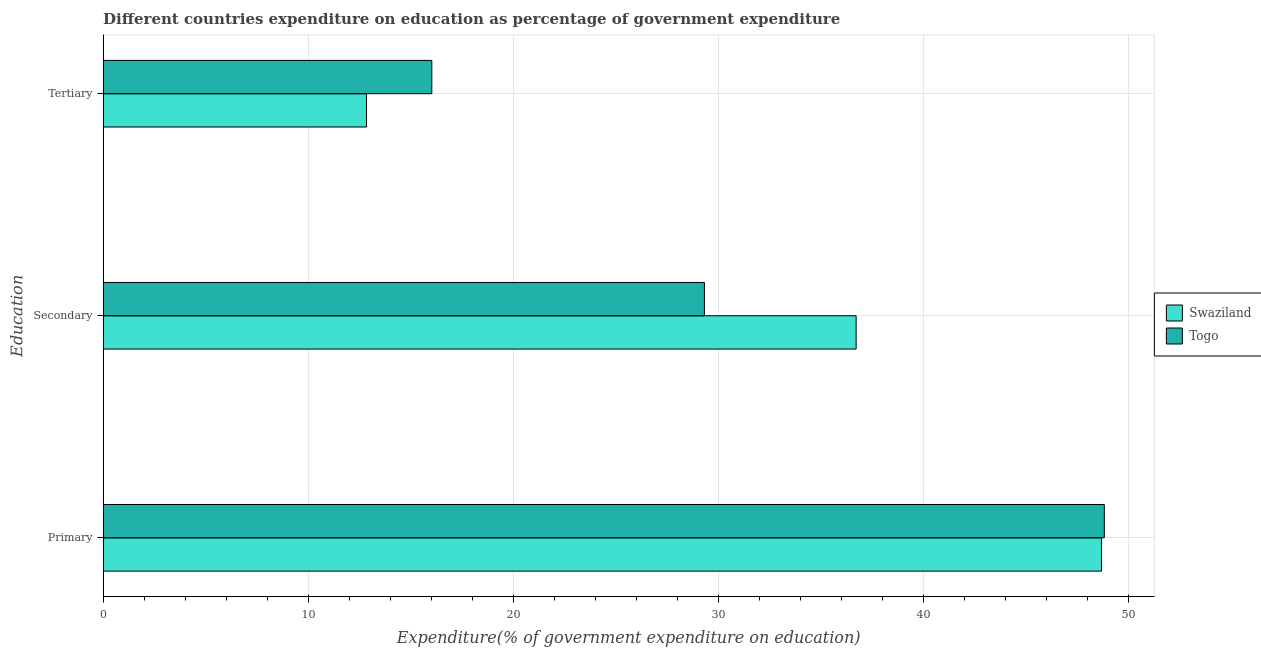Are the number of bars per tick equal to the number of legend labels?
Provide a short and direct response. Yes. How many bars are there on the 2nd tick from the top?
Keep it short and to the point. 2. What is the label of the 2nd group of bars from the top?
Your answer should be compact. Secondary. What is the expenditure on primary education in Swaziland?
Your answer should be very brief. 48.67. Across all countries, what is the maximum expenditure on secondary education?
Your answer should be very brief. 36.71. Across all countries, what is the minimum expenditure on tertiary education?
Give a very brief answer. 12.84. In which country was the expenditure on secondary education maximum?
Provide a short and direct response. Swaziland. In which country was the expenditure on tertiary education minimum?
Your answer should be very brief. Swaziland. What is the total expenditure on tertiary education in the graph?
Your answer should be very brief. 28.86. What is the difference between the expenditure on primary education in Togo and that in Swaziland?
Offer a very short reply. 0.14. What is the difference between the expenditure on secondary education in Swaziland and the expenditure on primary education in Togo?
Keep it short and to the point. -12.1. What is the average expenditure on tertiary education per country?
Make the answer very short. 14.43. What is the difference between the expenditure on tertiary education and expenditure on secondary education in Togo?
Provide a succinct answer. -13.29. In how many countries, is the expenditure on secondary education greater than 24 %?
Keep it short and to the point. 2. What is the ratio of the expenditure on primary education in Swaziland to that in Togo?
Ensure brevity in your answer.  1. Is the expenditure on primary education in Swaziland less than that in Togo?
Offer a very short reply. Yes. Is the difference between the expenditure on secondary education in Swaziland and Togo greater than the difference between the expenditure on tertiary education in Swaziland and Togo?
Offer a very short reply. Yes. What is the difference between the highest and the second highest expenditure on secondary education?
Offer a very short reply. 7.4. What is the difference between the highest and the lowest expenditure on tertiary education?
Offer a terse response. 3.18. Is the sum of the expenditure on tertiary education in Swaziland and Togo greater than the maximum expenditure on secondary education across all countries?
Ensure brevity in your answer.  No. What does the 1st bar from the top in Secondary represents?
Your response must be concise. Togo. What does the 2nd bar from the bottom in Primary represents?
Your response must be concise. Togo. Does the graph contain grids?
Provide a short and direct response. Yes. How many legend labels are there?
Keep it short and to the point. 2. How are the legend labels stacked?
Your answer should be compact. Vertical. What is the title of the graph?
Your answer should be compact. Different countries expenditure on education as percentage of government expenditure. Does "Pakistan" appear as one of the legend labels in the graph?
Provide a short and direct response. No. What is the label or title of the X-axis?
Ensure brevity in your answer.  Expenditure(% of government expenditure on education). What is the label or title of the Y-axis?
Ensure brevity in your answer.  Education. What is the Expenditure(% of government expenditure on education) in Swaziland in Primary?
Provide a succinct answer. 48.67. What is the Expenditure(% of government expenditure on education) in Togo in Primary?
Provide a succinct answer. 48.8. What is the Expenditure(% of government expenditure on education) in Swaziland in Secondary?
Provide a succinct answer. 36.71. What is the Expenditure(% of government expenditure on education) in Togo in Secondary?
Keep it short and to the point. 29.31. What is the Expenditure(% of government expenditure on education) of Swaziland in Tertiary?
Provide a succinct answer. 12.84. What is the Expenditure(% of government expenditure on education) of Togo in Tertiary?
Provide a short and direct response. 16.02. Across all Education, what is the maximum Expenditure(% of government expenditure on education) of Swaziland?
Ensure brevity in your answer.  48.67. Across all Education, what is the maximum Expenditure(% of government expenditure on education) of Togo?
Your response must be concise. 48.8. Across all Education, what is the minimum Expenditure(% of government expenditure on education) in Swaziland?
Offer a very short reply. 12.84. Across all Education, what is the minimum Expenditure(% of government expenditure on education) in Togo?
Make the answer very short. 16.02. What is the total Expenditure(% of government expenditure on education) of Swaziland in the graph?
Keep it short and to the point. 98.21. What is the total Expenditure(% of government expenditure on education) of Togo in the graph?
Keep it short and to the point. 94.14. What is the difference between the Expenditure(% of government expenditure on education) in Swaziland in Primary and that in Secondary?
Your response must be concise. 11.96. What is the difference between the Expenditure(% of government expenditure on education) of Togo in Primary and that in Secondary?
Give a very brief answer. 19.49. What is the difference between the Expenditure(% of government expenditure on education) of Swaziland in Primary and that in Tertiary?
Make the answer very short. 35.83. What is the difference between the Expenditure(% of government expenditure on education) in Togo in Primary and that in Tertiary?
Your answer should be very brief. 32.78. What is the difference between the Expenditure(% of government expenditure on education) in Swaziland in Secondary and that in Tertiary?
Make the answer very short. 23.87. What is the difference between the Expenditure(% of government expenditure on education) of Togo in Secondary and that in Tertiary?
Provide a succinct answer. 13.29. What is the difference between the Expenditure(% of government expenditure on education) of Swaziland in Primary and the Expenditure(% of government expenditure on education) of Togo in Secondary?
Offer a terse response. 19.36. What is the difference between the Expenditure(% of government expenditure on education) of Swaziland in Primary and the Expenditure(% of government expenditure on education) of Togo in Tertiary?
Offer a terse response. 32.65. What is the difference between the Expenditure(% of government expenditure on education) in Swaziland in Secondary and the Expenditure(% of government expenditure on education) in Togo in Tertiary?
Keep it short and to the point. 20.68. What is the average Expenditure(% of government expenditure on education) in Swaziland per Education?
Provide a short and direct response. 32.74. What is the average Expenditure(% of government expenditure on education) of Togo per Education?
Offer a very short reply. 31.38. What is the difference between the Expenditure(% of government expenditure on education) in Swaziland and Expenditure(% of government expenditure on education) in Togo in Primary?
Keep it short and to the point. -0.14. What is the difference between the Expenditure(% of government expenditure on education) of Swaziland and Expenditure(% of government expenditure on education) of Togo in Secondary?
Make the answer very short. 7.4. What is the difference between the Expenditure(% of government expenditure on education) in Swaziland and Expenditure(% of government expenditure on education) in Togo in Tertiary?
Your answer should be compact. -3.18. What is the ratio of the Expenditure(% of government expenditure on education) of Swaziland in Primary to that in Secondary?
Make the answer very short. 1.33. What is the ratio of the Expenditure(% of government expenditure on education) of Togo in Primary to that in Secondary?
Provide a short and direct response. 1.67. What is the ratio of the Expenditure(% of government expenditure on education) of Swaziland in Primary to that in Tertiary?
Offer a terse response. 3.79. What is the ratio of the Expenditure(% of government expenditure on education) in Togo in Primary to that in Tertiary?
Provide a short and direct response. 3.05. What is the ratio of the Expenditure(% of government expenditure on education) in Swaziland in Secondary to that in Tertiary?
Offer a very short reply. 2.86. What is the ratio of the Expenditure(% of government expenditure on education) of Togo in Secondary to that in Tertiary?
Your response must be concise. 1.83. What is the difference between the highest and the second highest Expenditure(% of government expenditure on education) of Swaziland?
Make the answer very short. 11.96. What is the difference between the highest and the second highest Expenditure(% of government expenditure on education) of Togo?
Provide a short and direct response. 19.49. What is the difference between the highest and the lowest Expenditure(% of government expenditure on education) of Swaziland?
Offer a very short reply. 35.83. What is the difference between the highest and the lowest Expenditure(% of government expenditure on education) of Togo?
Your answer should be very brief. 32.78. 